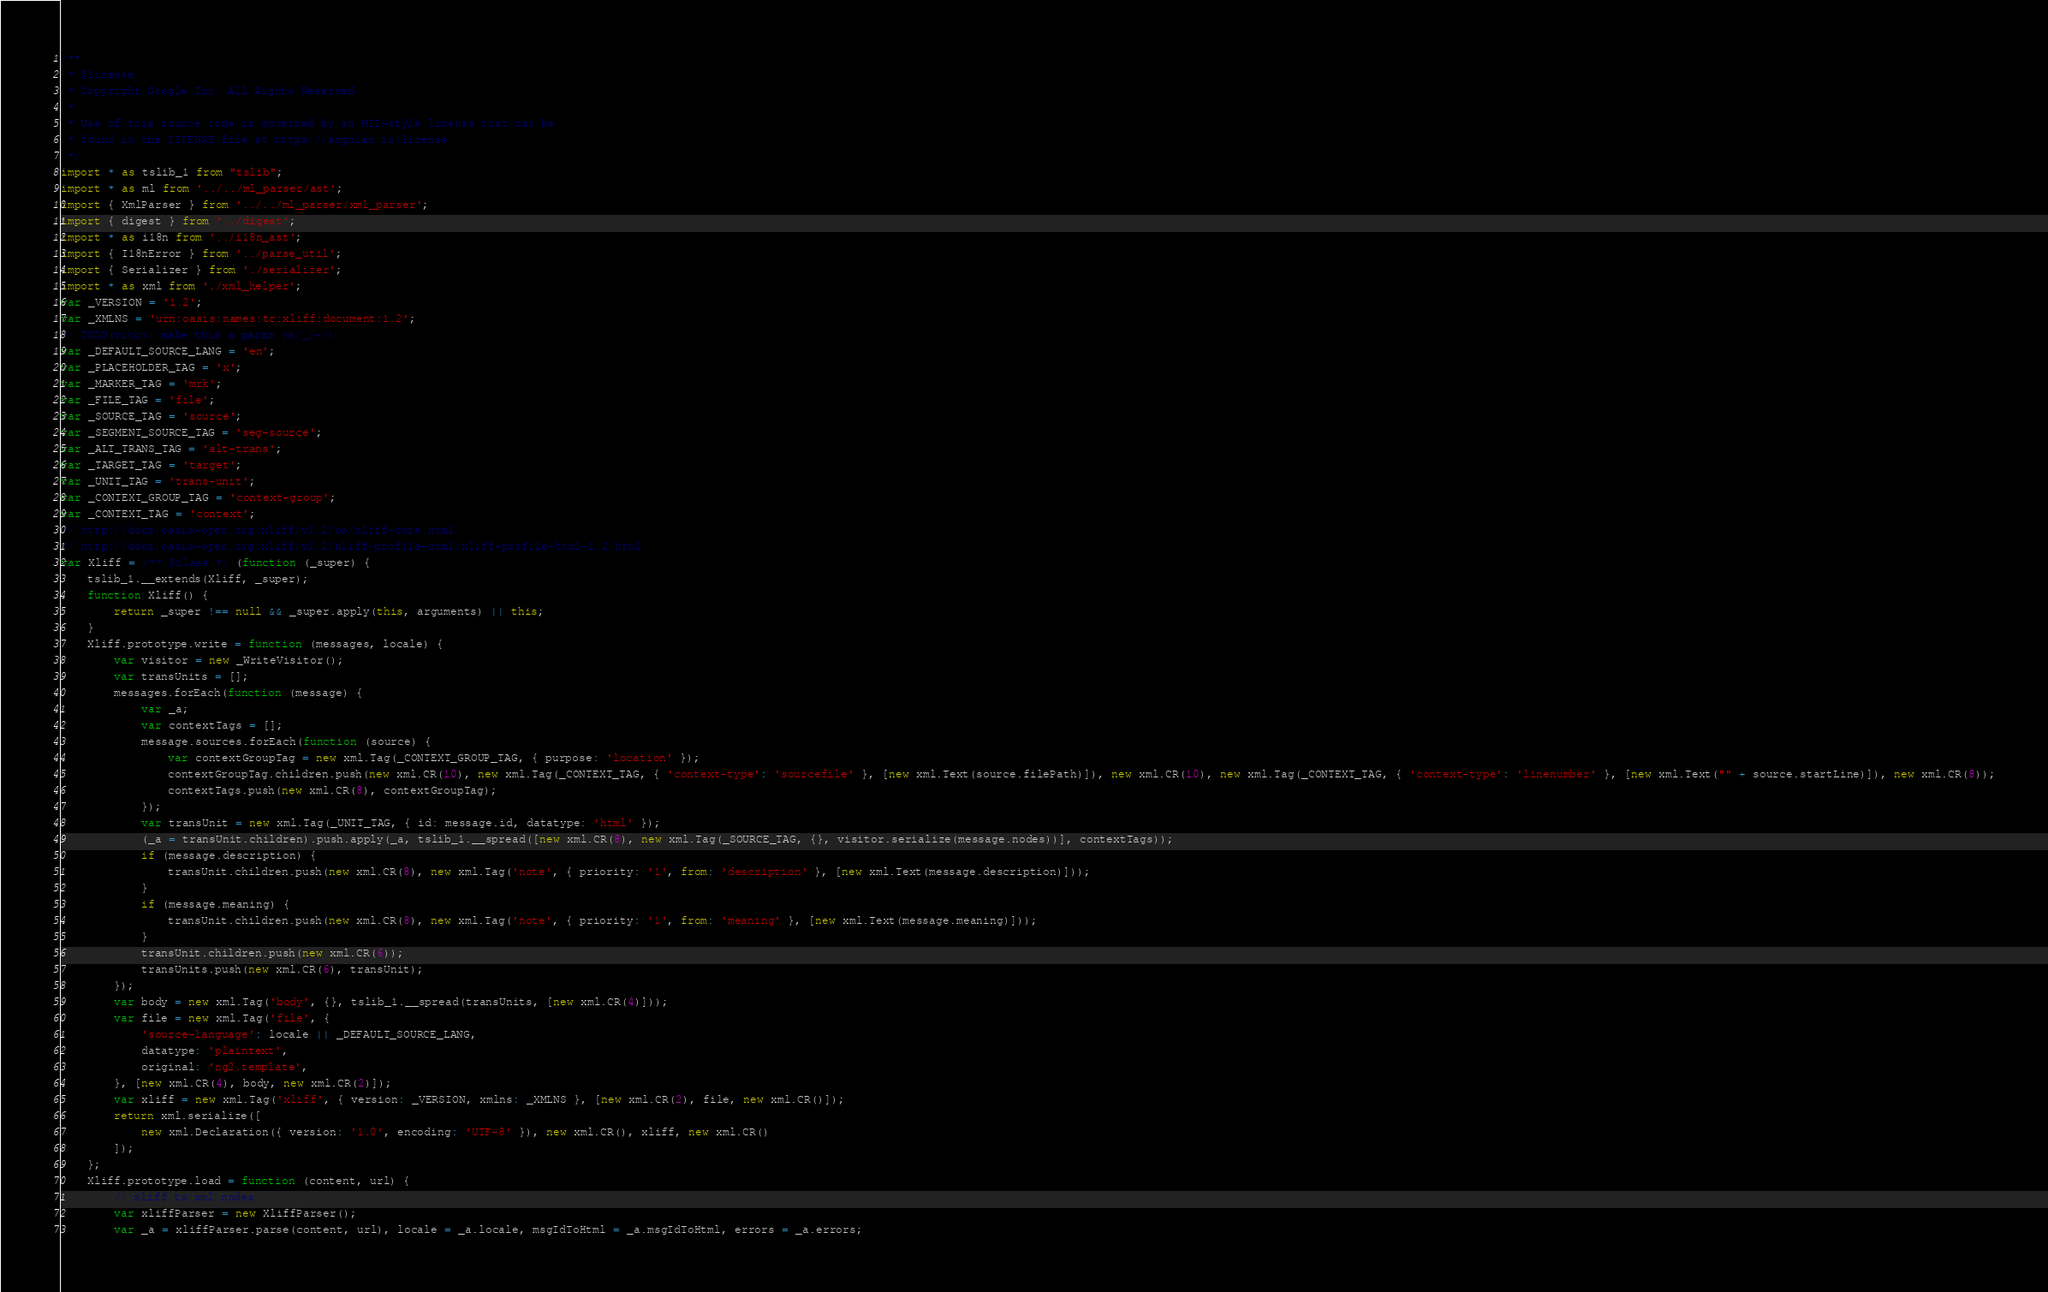<code> <loc_0><loc_0><loc_500><loc_500><_JavaScript_>/**
 * @license
 * Copyright Google Inc. All Rights Reserved.
 *
 * Use of this source code is governed by an MIT-style license that can be
 * found in the LICENSE file at https://angular.io/license
 */
import * as tslib_1 from "tslib";
import * as ml from '../../ml_parser/ast';
import { XmlParser } from '../../ml_parser/xml_parser';
import { digest } from '../digest';
import * as i18n from '../i18n_ast';
import { I18nError } from '../parse_util';
import { Serializer } from './serializer';
import * as xml from './xml_helper';
var _VERSION = '1.2';
var _XMLNS = 'urn:oasis:names:tc:xliff:document:1.2';
// TODO(vicb): make this a param (s/_/-/)
var _DEFAULT_SOURCE_LANG = 'en';
var _PLACEHOLDER_TAG = 'x';
var _MARKER_TAG = 'mrk';
var _FILE_TAG = 'file';
var _SOURCE_TAG = 'source';
var _SEGMENT_SOURCE_TAG = 'seg-source';
var _ALT_TRANS_TAG = 'alt-trans';
var _TARGET_TAG = 'target';
var _UNIT_TAG = 'trans-unit';
var _CONTEXT_GROUP_TAG = 'context-group';
var _CONTEXT_TAG = 'context';
// http://docs.oasis-open.org/xliff/v1.2/os/xliff-core.html
// http://docs.oasis-open.org/xliff/v1.2/xliff-profile-html/xliff-profile-html-1.2.html
var Xliff = /** @class */ (function (_super) {
    tslib_1.__extends(Xliff, _super);
    function Xliff() {
        return _super !== null && _super.apply(this, arguments) || this;
    }
    Xliff.prototype.write = function (messages, locale) {
        var visitor = new _WriteVisitor();
        var transUnits = [];
        messages.forEach(function (message) {
            var _a;
            var contextTags = [];
            message.sources.forEach(function (source) {
                var contextGroupTag = new xml.Tag(_CONTEXT_GROUP_TAG, { purpose: 'location' });
                contextGroupTag.children.push(new xml.CR(10), new xml.Tag(_CONTEXT_TAG, { 'context-type': 'sourcefile' }, [new xml.Text(source.filePath)]), new xml.CR(10), new xml.Tag(_CONTEXT_TAG, { 'context-type': 'linenumber' }, [new xml.Text("" + source.startLine)]), new xml.CR(8));
                contextTags.push(new xml.CR(8), contextGroupTag);
            });
            var transUnit = new xml.Tag(_UNIT_TAG, { id: message.id, datatype: 'html' });
            (_a = transUnit.children).push.apply(_a, tslib_1.__spread([new xml.CR(8), new xml.Tag(_SOURCE_TAG, {}, visitor.serialize(message.nodes))], contextTags));
            if (message.description) {
                transUnit.children.push(new xml.CR(8), new xml.Tag('note', { priority: '1', from: 'description' }, [new xml.Text(message.description)]));
            }
            if (message.meaning) {
                transUnit.children.push(new xml.CR(8), new xml.Tag('note', { priority: '1', from: 'meaning' }, [new xml.Text(message.meaning)]));
            }
            transUnit.children.push(new xml.CR(6));
            transUnits.push(new xml.CR(6), transUnit);
        });
        var body = new xml.Tag('body', {}, tslib_1.__spread(transUnits, [new xml.CR(4)]));
        var file = new xml.Tag('file', {
            'source-language': locale || _DEFAULT_SOURCE_LANG,
            datatype: 'plaintext',
            original: 'ng2.template',
        }, [new xml.CR(4), body, new xml.CR(2)]);
        var xliff = new xml.Tag('xliff', { version: _VERSION, xmlns: _XMLNS }, [new xml.CR(2), file, new xml.CR()]);
        return xml.serialize([
            new xml.Declaration({ version: '1.0', encoding: 'UTF-8' }), new xml.CR(), xliff, new xml.CR()
        ]);
    };
    Xliff.prototype.load = function (content, url) {
        // xliff to xml nodes
        var xliffParser = new XliffParser();
        var _a = xliffParser.parse(content, url), locale = _a.locale, msgIdToHtml = _a.msgIdToHtml, errors = _a.errors;</code> 